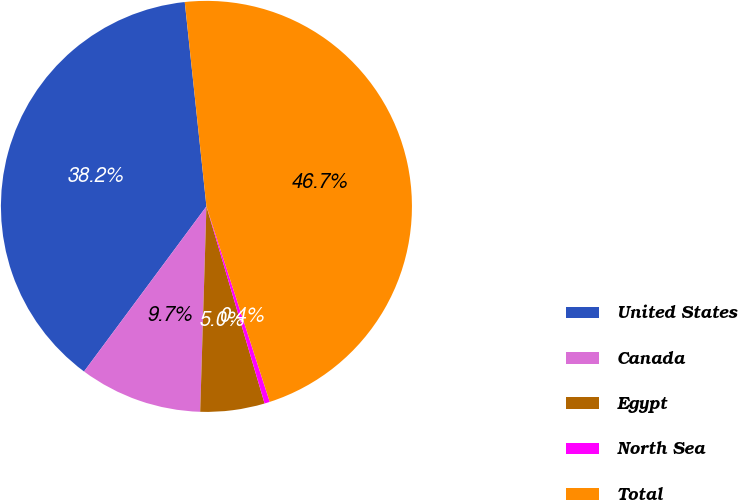Convert chart. <chart><loc_0><loc_0><loc_500><loc_500><pie_chart><fcel>United States<fcel>Canada<fcel>Egypt<fcel>North Sea<fcel>Total<nl><fcel>38.17%<fcel>9.67%<fcel>5.05%<fcel>0.42%<fcel>46.7%<nl></chart> 